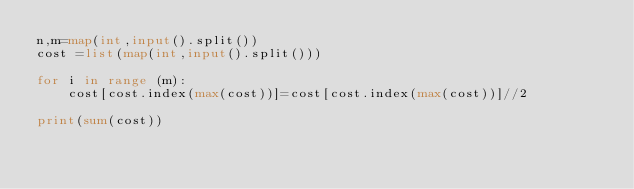Convert code to text. <code><loc_0><loc_0><loc_500><loc_500><_Python_>n,m=map(int,input().split())
cost =list(map(int,input().split()))

for i in range (m):
    cost[cost.index(max(cost))]=cost[cost.index(max(cost))]//2

print(sum(cost))
</code> 